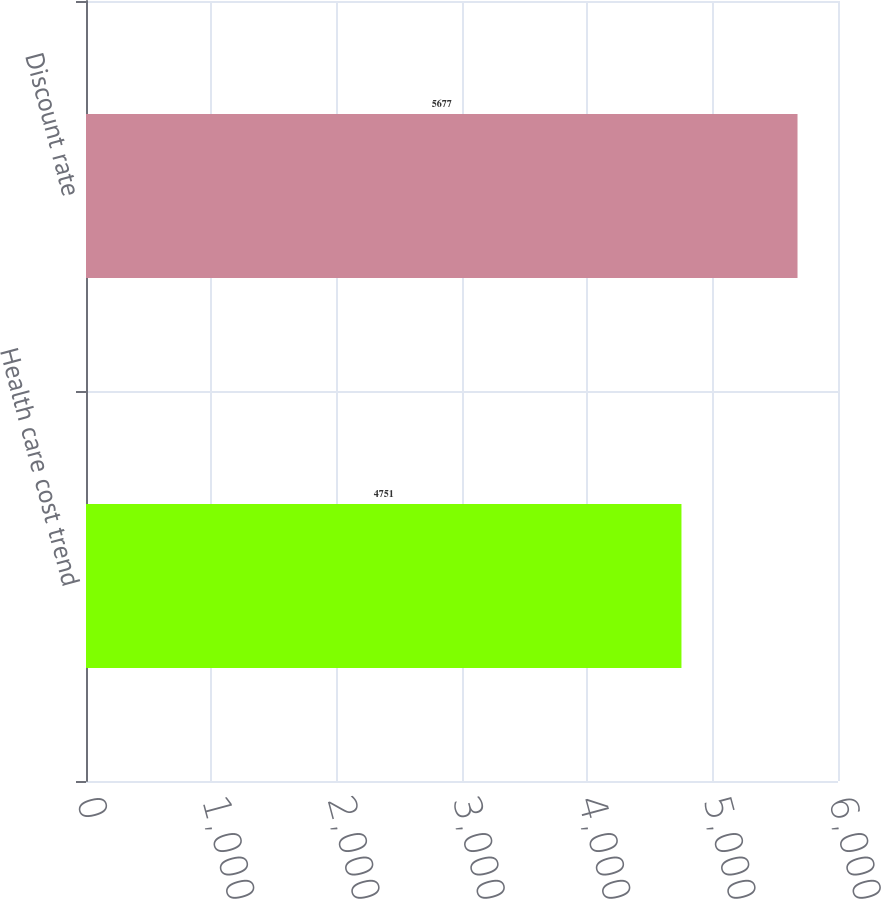Convert chart to OTSL. <chart><loc_0><loc_0><loc_500><loc_500><bar_chart><fcel>Health care cost trend<fcel>Discount rate<nl><fcel>4751<fcel>5677<nl></chart> 